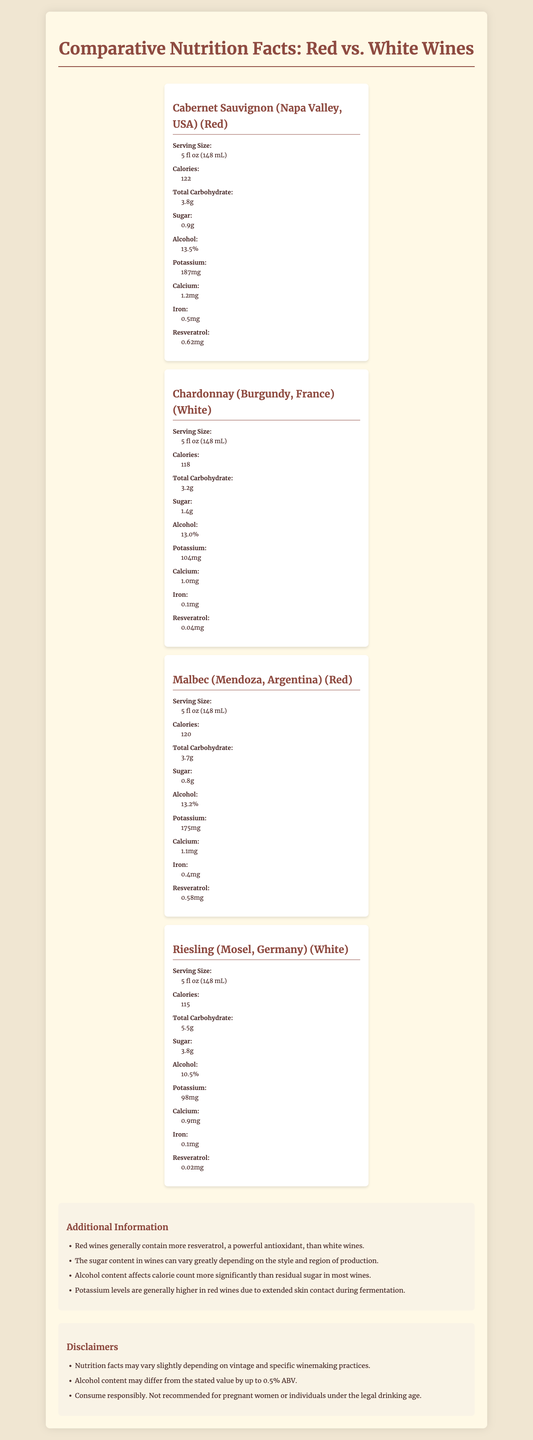what is the serving size for the wines? The document specifies at the top “Serving Size: 5 fl oz (148 mL)”.
Answer: 5 fl oz (148 mL) how many calories are in a serving of Cabernet Sauvignon (Napa Valley, USA)? Under the nutrition facts for Cabernet Sauvignon (Napa Valley, USA), it lists 122 calories.
Answer: 122 which type of wine typically has more resveratrol: red or white? According to the additional information, red wines generally contain more resveratrol, a powerful antioxidant, than white wines.
Answer: Red what is the alcohol content of Riesling (Mosel, Germany)? The nutrition facts for Riesling (Mosel, Germany) list an alcohol content of 10.5%.
Answer: 10.5% which wine contains the most sugar? Riesling contains 3.8g of sugar according to its nutrition facts, which is the highest among the listed wines.
Answer: Riesling (Mosel, Germany) which wine has the highest potassium content? 
a. Malbec (Mendoza, Argentina)
b. Cabernet Sauvignon (Napa Valley, USA)
c. Chardonnay (Burgundy, France)
d. Riesling (Mosel, Germany) Cabernet Sauvignon (Napa Valley, USA) has 187 mg of potassium, which is the highest among the listed wines.
Answer: b which of the following wines has the lowest calorie count?
I. Malbec (Mendoza, Argentina)
II. Chardonnay (Burgundy, France)
III. Riesling (Mosel, Germany) Riesling (Mosel, Germany) has 115 calories, the lowest among the 3 options.
Answer: III is the following statement true or false? "The alcohol content affects calorie count more significantly than residual sugar in most wines." According to the additional information provided in the document.
Answer: True summarize the main idea of the document. The document helps to compare and contrast the nutritional components of selected wines while offering insights into how different factors influence their nutritional profiles and potency.
Answer: The document compares the nutrition facts of different red and white wines from various regions. It highlights serving size, calorie count, carbohydrate, sugar, alcohol content, and mineral content such as potassium, calcium, and iron, along with the antioxidant resveratrol. Additional information is provided on the health benefits of red wines, the variability in sugar content, and the impact of alcohol and fermentation on the nutritional profile. Disclaimers mention potential variations due to winemaking practices. how does potassium content in wine relate to winemaking processes? This fact is highlighted in the additional information, which explains the effect of winemaking processes on mineral content.
Answer: Potassium levels are generally higher in red wines due to extended skin contact during fermentation. can you determine the vintage of the wines listed in the document? The document does not provide vintage details for any of the wines.
Answer: Not enough information 